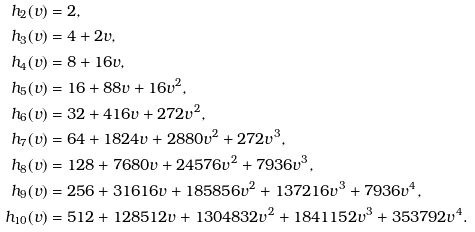Convert formula to latex. <formula><loc_0><loc_0><loc_500><loc_500>h _ { 2 } ( v ) & = 2 , \\ h _ { 3 } ( v ) & = 4 + 2 v , \\ h _ { 4 } ( v ) & = 8 + 1 6 v , \\ h _ { 5 } ( v ) & = 1 6 + 8 8 v + 1 6 v ^ { 2 } , \\ h _ { 6 } ( v ) & = 3 2 + 4 1 6 v + 2 7 2 v ^ { 2 } , \\ h _ { 7 } ( v ) & = 6 4 + 1 8 2 4 v + 2 8 8 0 v ^ { 2 } + 2 7 2 v ^ { 3 } , \\ h _ { 8 } ( v ) & = 1 2 8 + 7 6 8 0 v + 2 4 5 7 6 v ^ { 2 } + 7 9 3 6 v ^ { 3 } , \\ h _ { 9 } ( v ) & = 2 5 6 + 3 1 6 1 6 v + 1 8 5 8 5 6 v ^ { 2 } + 1 3 7 2 1 6 v ^ { 3 } + 7 9 3 6 v ^ { 4 } , \\ h _ { 1 0 } ( v ) & = 5 1 2 + 1 2 8 5 1 2 v + 1 3 0 4 8 3 2 v ^ { 2 } + 1 8 4 1 1 5 2 v ^ { 3 } + 3 5 3 7 9 2 v ^ { 4 } .</formula> 